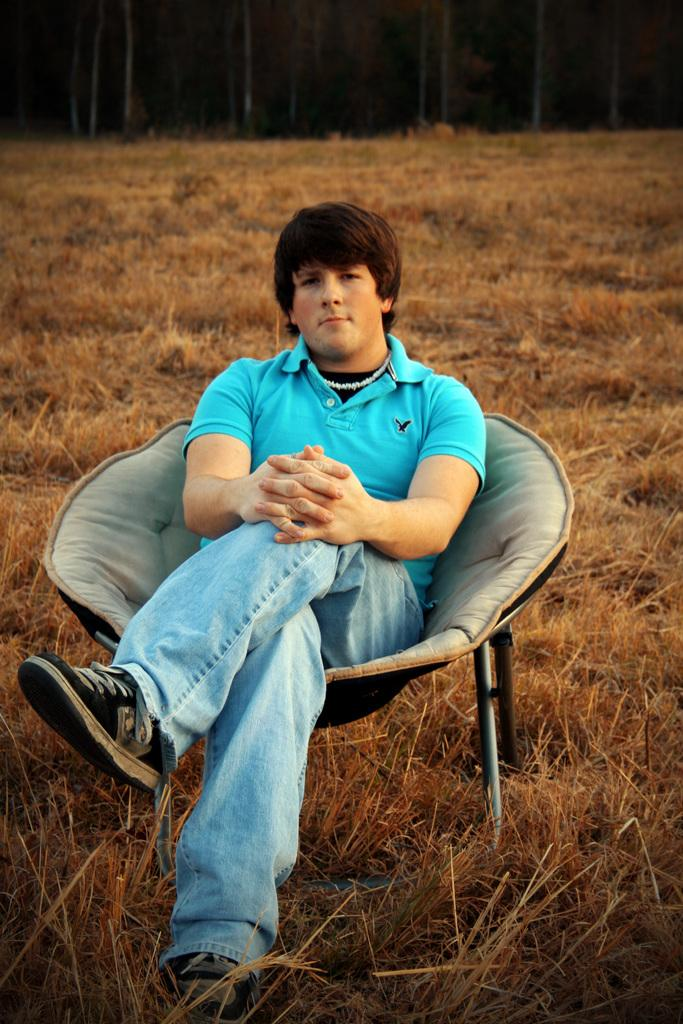What is the person in the image doing? The person is sitting in the image. What color is the shirt the person is wearing? The person is wearing a blue shirt. What color are the pants the person is wearing? The person is wearing blue pants. What can be seen in the background of the image? The background of the image includes dried grass in brown color. How many bricks can be seen in the person's grip in the image? There are no bricks present in the image, and the person is not gripping anything. 